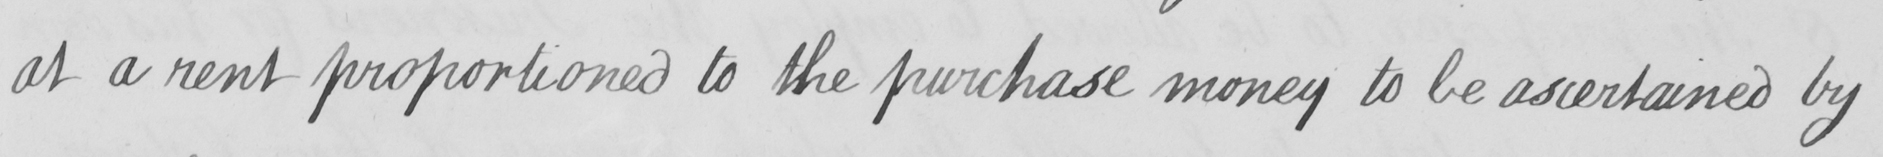What does this handwritten line say? at a rent proportioned to the purchase money to be ascertained by 